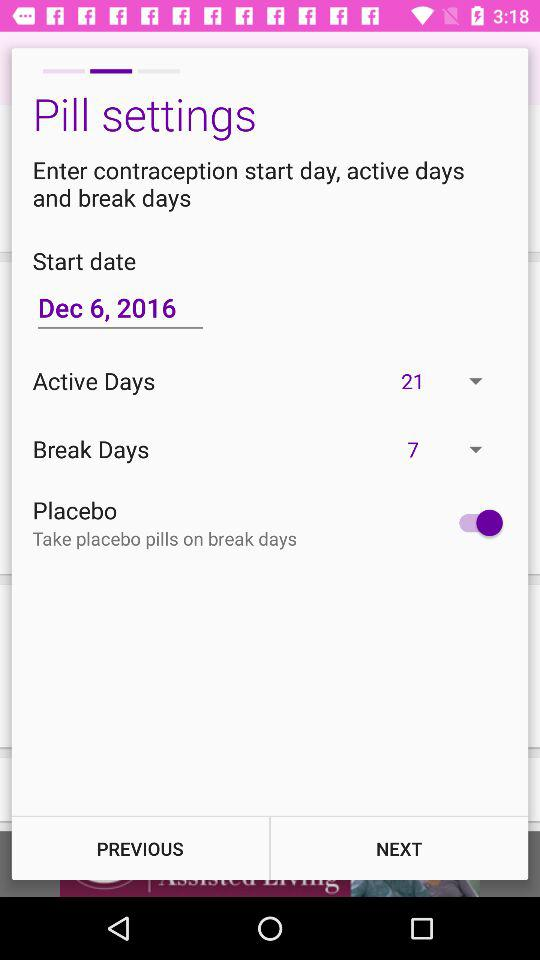What is the status of the "Placebo"? The status is on. 